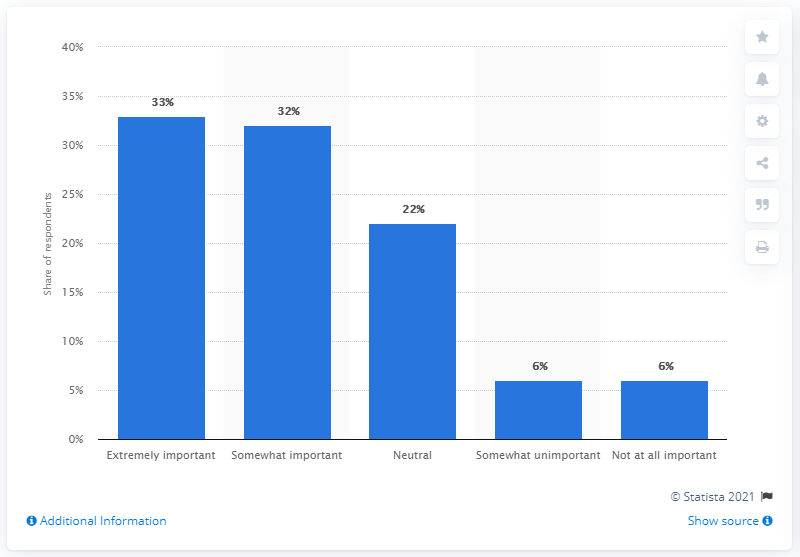Draw attention to some important aspects in this diagram. According to consumer ratings, only 6% of consumers considered innovation and technology to be unimportant. 